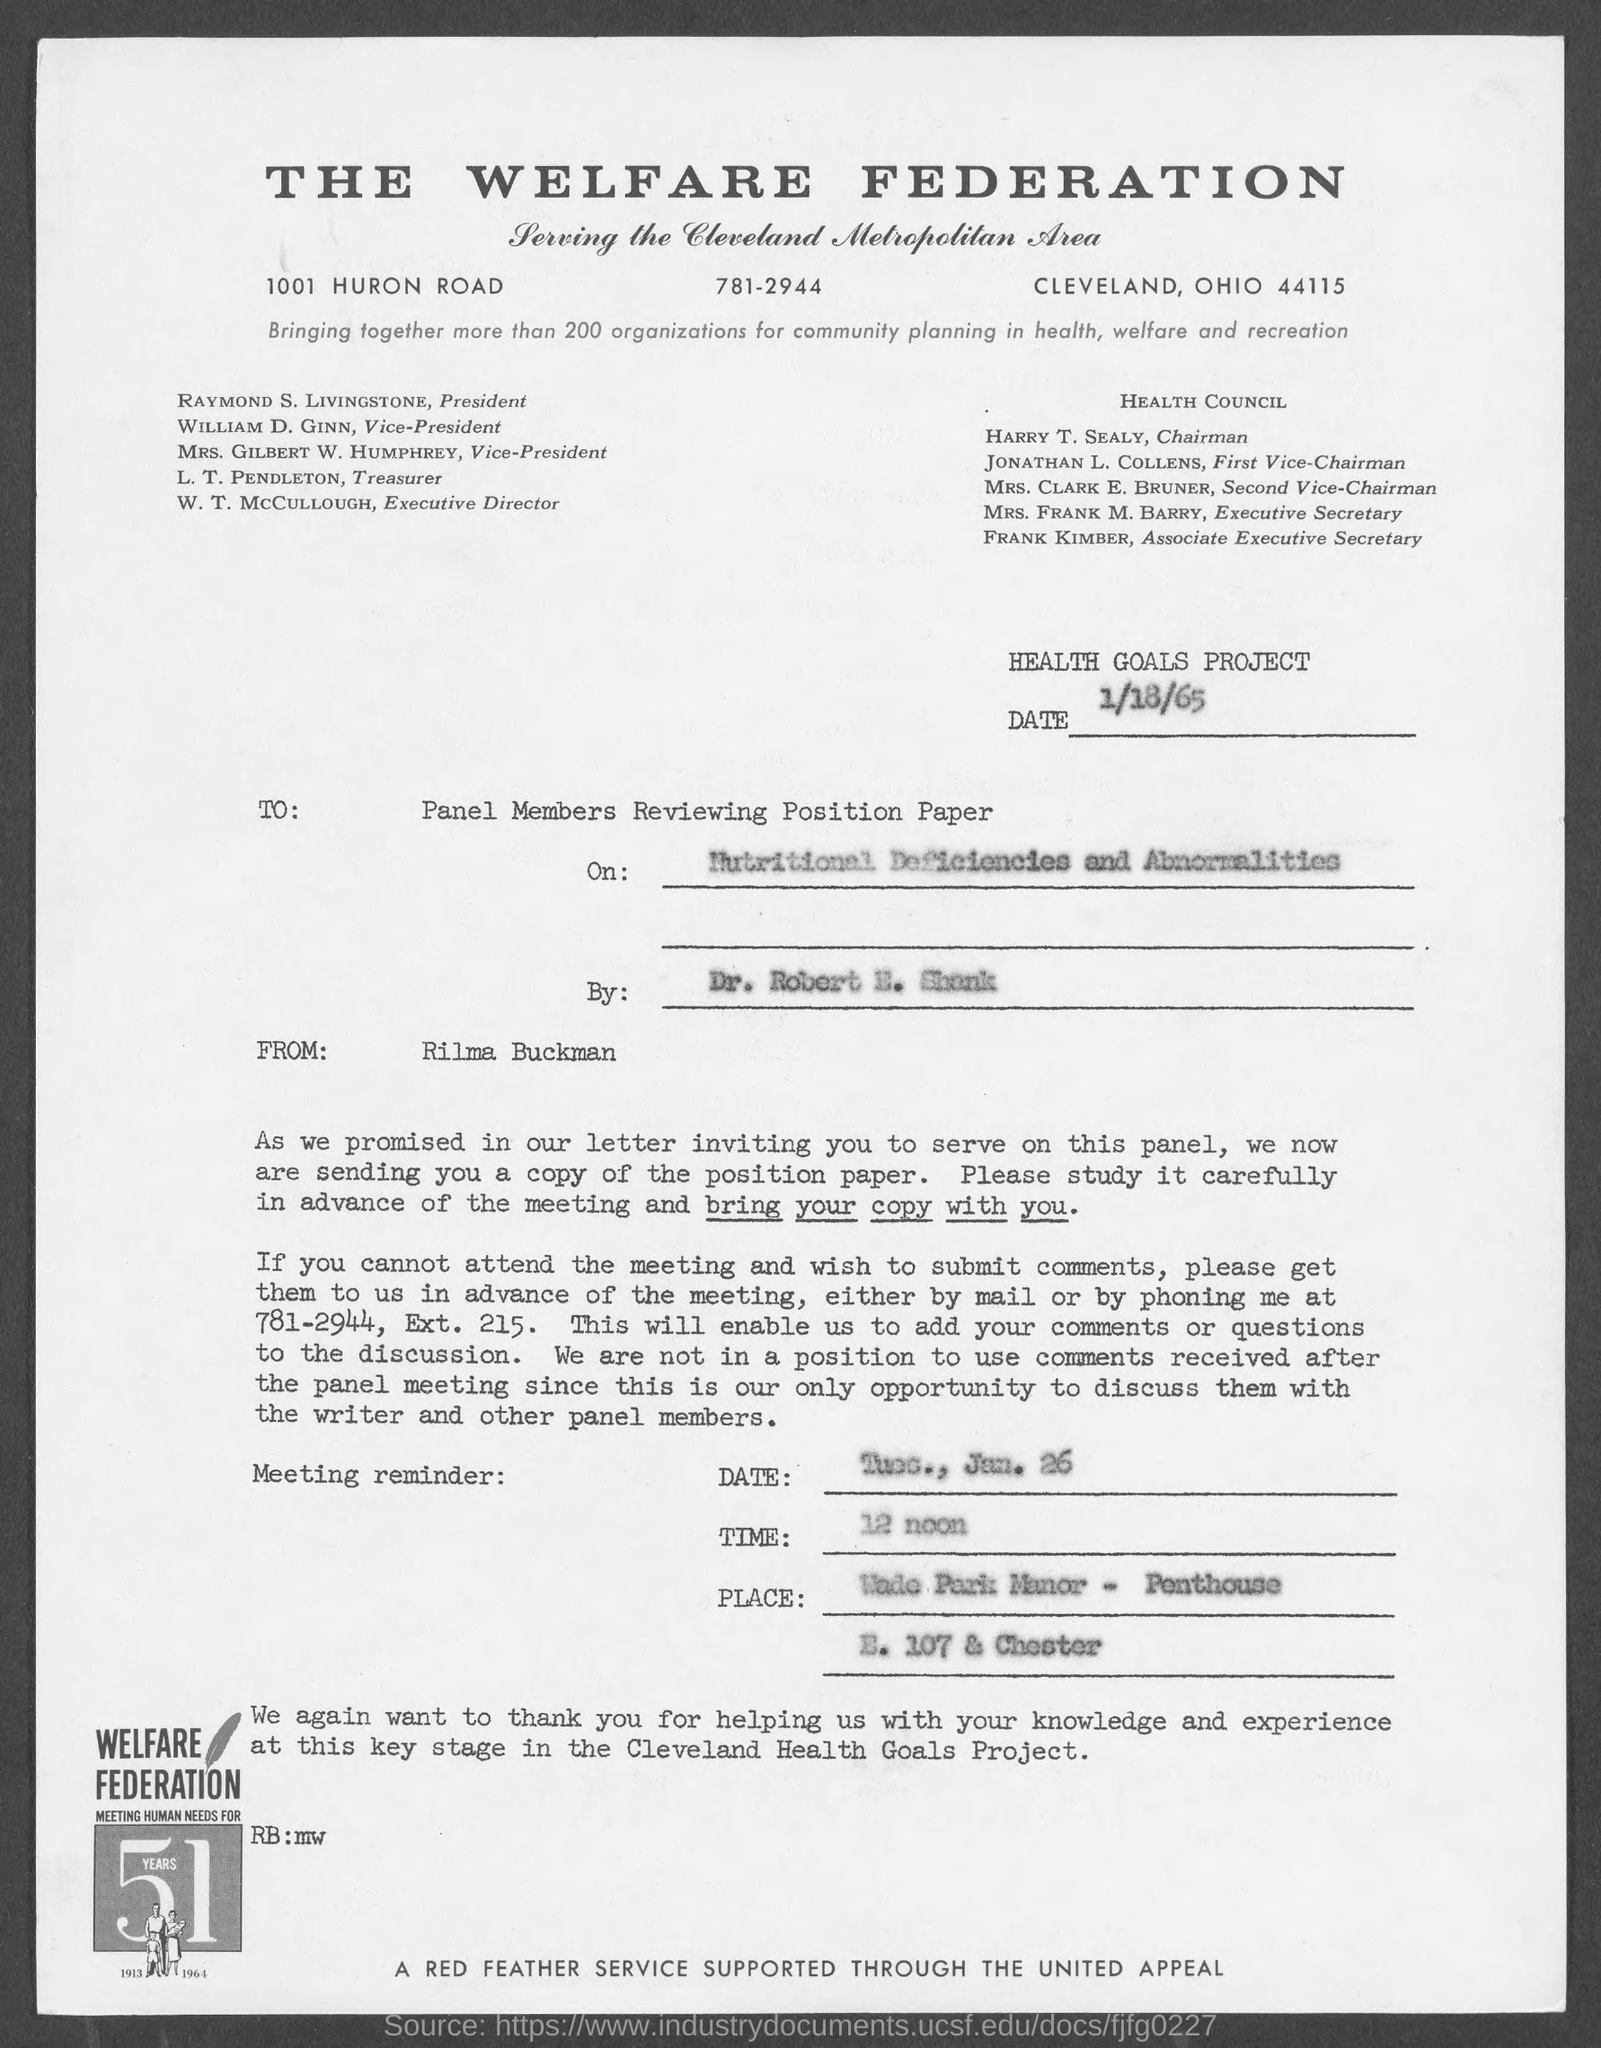To whom the letter is written?
Provide a succinct answer. Panel Members Reviewing Position Paper. By whom letter is written?
Make the answer very short. Rilma Buckman. At what time meeting is held?
Your answer should be very brief. 12 noon. 